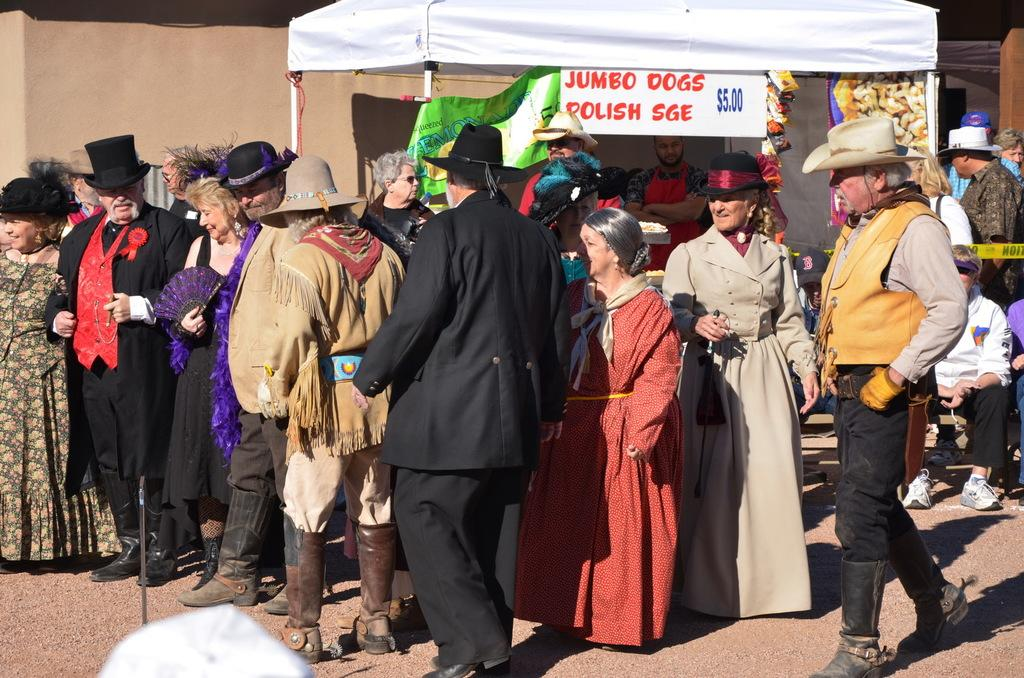What is the main subject of the image? The main subject of the image is a crowd of people. What are the people in the crowd wearing? The people in the crowd are wearing costumes. What structures or objects can be seen in the image? There is a tent, a board, a fence, chairs, and a building visible in the image. What can be inferred about the time of day when the image was taken? The image was likely taken during the day, as there is no indication of darkness or artificial lighting. What type of fruit is being used to decorate the chairs in the image? There is no fruit visible in the image, and the chairs are not being decorated with any fruit. 